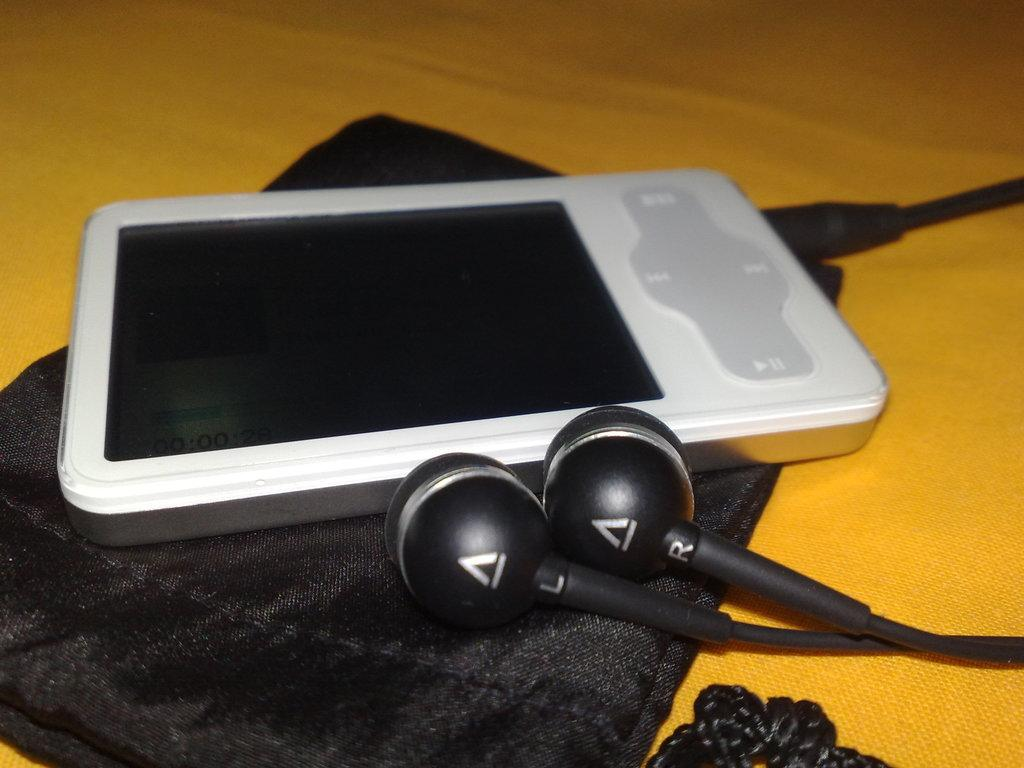What type of items are present in the image? There are electronic gadgets and earphones in the image. How are the electronic gadgets and earphones arranged in the image? The electronic gadgets and earphones are kept on a cloth. What type of apparel is visible in the image? There is no apparel visible in the image; it features electronic gadgets and earphones. Can you spot a snake in the image? There is no snake present in the image. What type of tin object is present in the image? There is no tin object present in the image. 